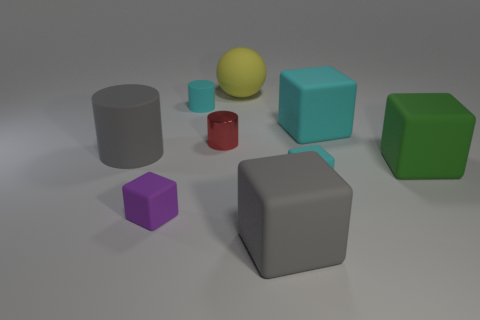Tell me more about the arrangement of objects. Is there any particular pattern or order they seem to be placed in? The objects are spread out somewhat randomly across a flat surface with no discernible pattern or order. They include cylinders, spheres, and cubes of various colors and sizes, set against a neutral background which draws attention to their geometric forms. 